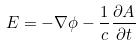Convert formula to latex. <formula><loc_0><loc_0><loc_500><loc_500>E = - \nabla \phi - \frac { 1 } { c } \frac { \partial A } { \partial t }</formula> 